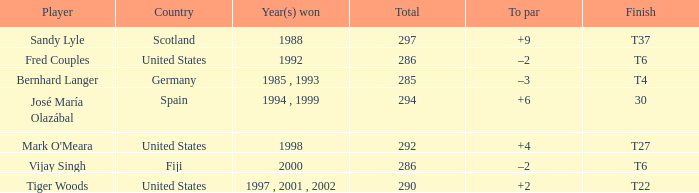What is the total for Bernhard Langer? 1.0. 